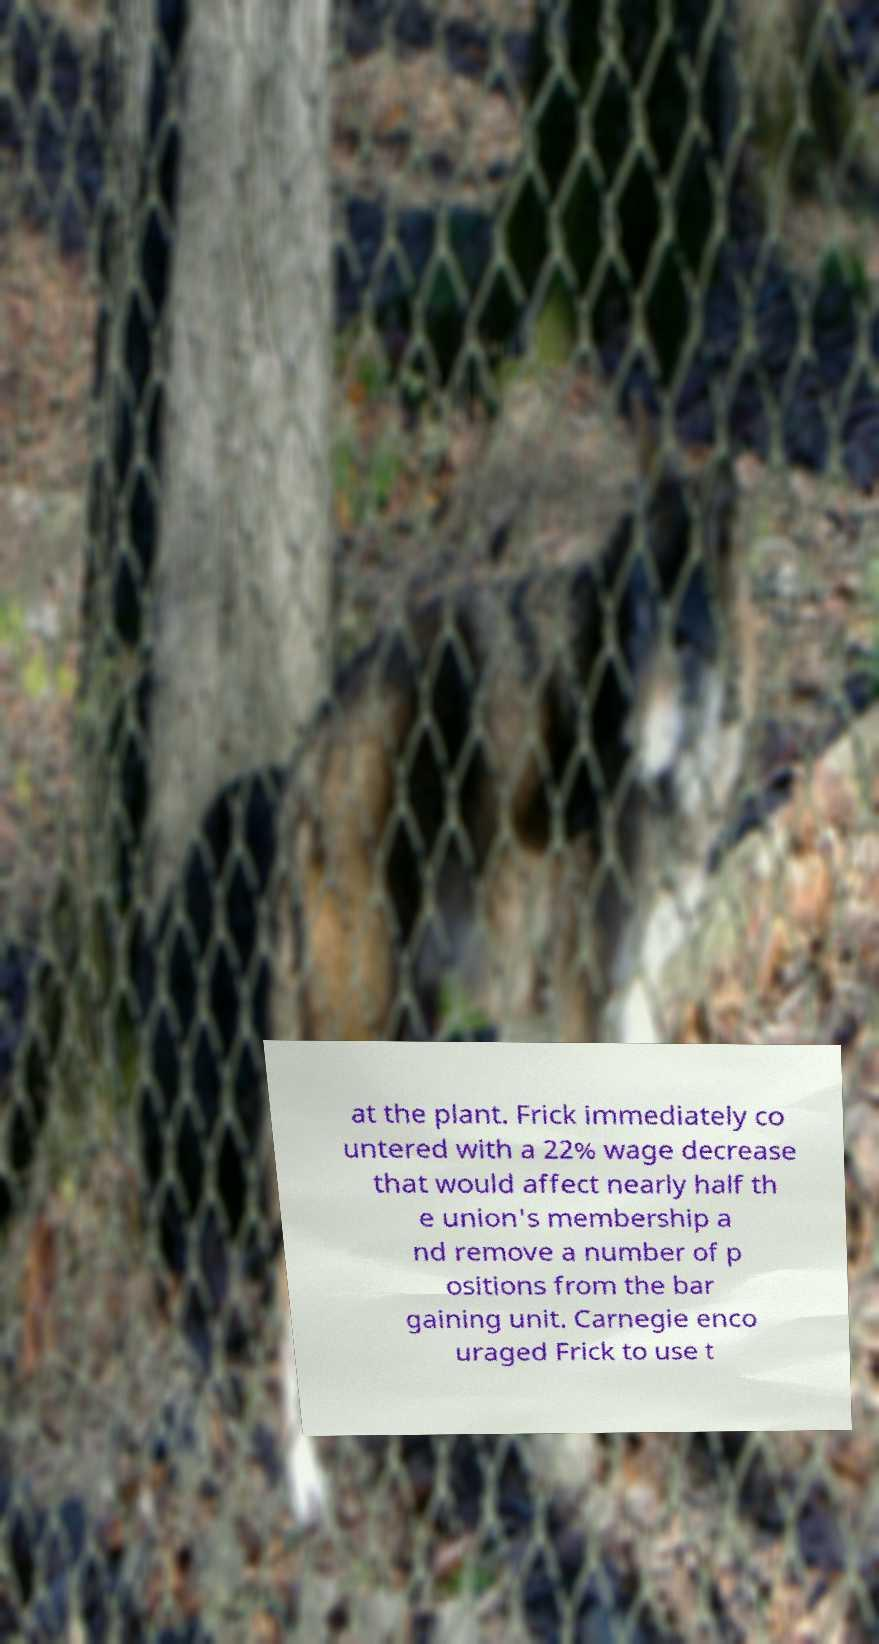For documentation purposes, I need the text within this image transcribed. Could you provide that? at the plant. Frick immediately co untered with a 22% wage decrease that would affect nearly half th e union's membership a nd remove a number of p ositions from the bar gaining unit. Carnegie enco uraged Frick to use t 